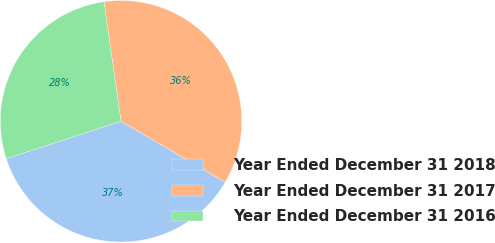Convert chart. <chart><loc_0><loc_0><loc_500><loc_500><pie_chart><fcel>Year Ended December 31 2018<fcel>Year Ended December 31 2017<fcel>Year Ended December 31 2016<nl><fcel>36.56%<fcel>35.69%<fcel>27.76%<nl></chart> 